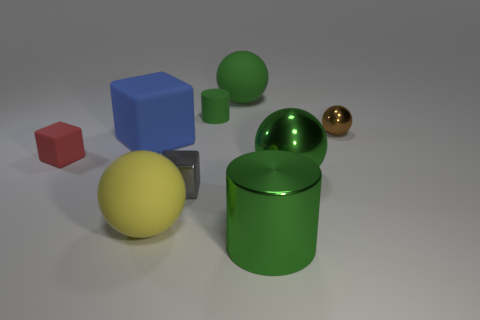Add 1 red cubes. How many objects exist? 10 Subtract all red blocks. How many blocks are left? 2 Subtract all green balls. How many balls are left? 2 Subtract 2 cubes. How many cubes are left? 1 Subtract all gray spheres. Subtract all red cylinders. How many spheres are left? 4 Subtract all cyan cylinders. How many cyan cubes are left? 0 Subtract all small matte blocks. Subtract all tiny blue rubber cubes. How many objects are left? 8 Add 3 green metallic balls. How many green metallic balls are left? 4 Add 4 tiny metallic blocks. How many tiny metallic blocks exist? 5 Subtract 0 purple cylinders. How many objects are left? 9 